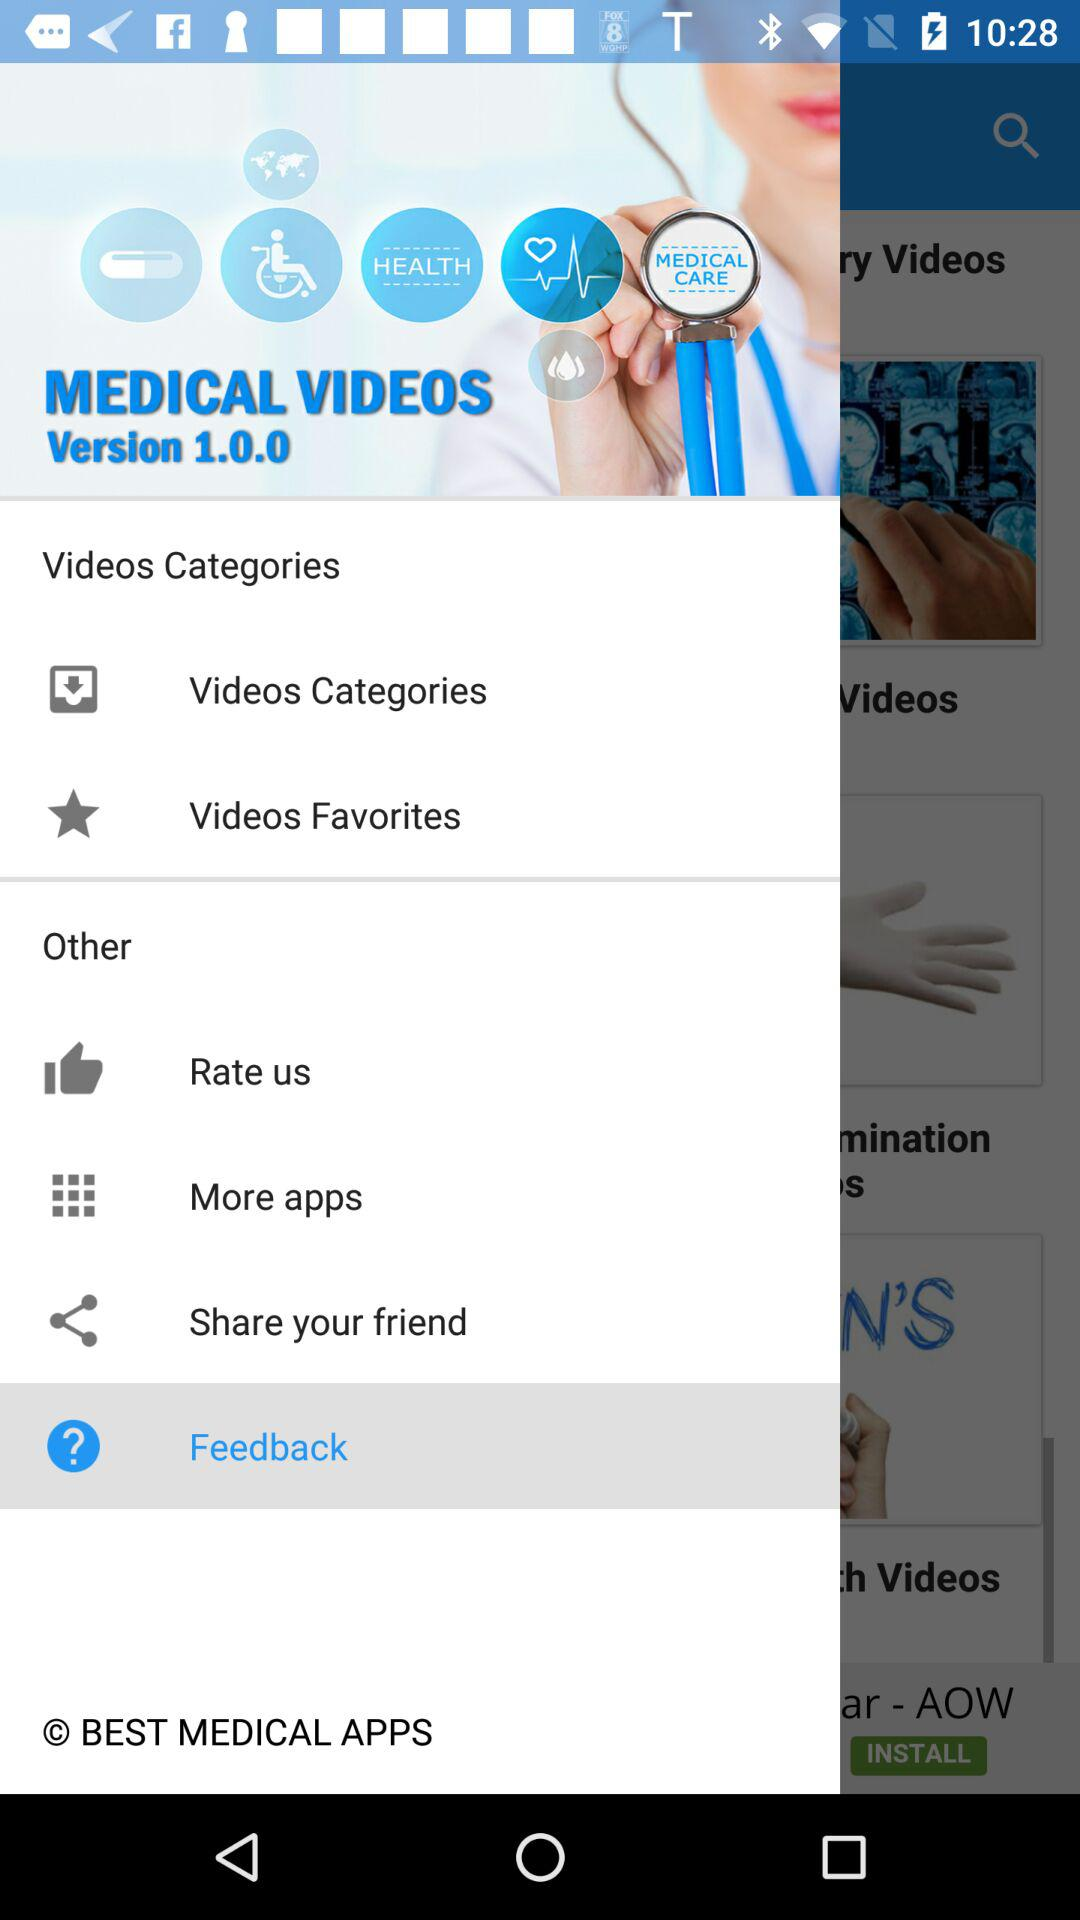What is the name of the application? The name of the application is "MEDICAL VIDEOS". 